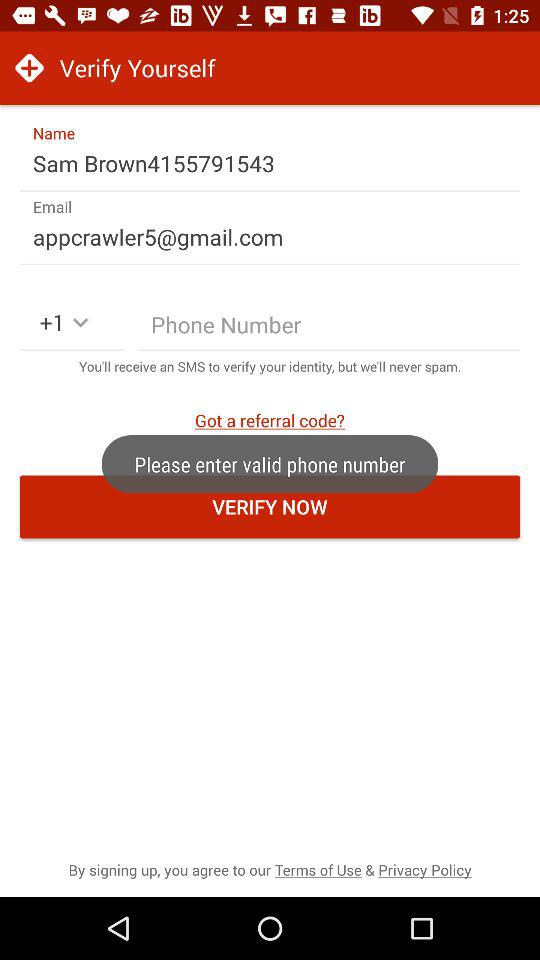What is the username? The username is "Sam Brown4155791543". 